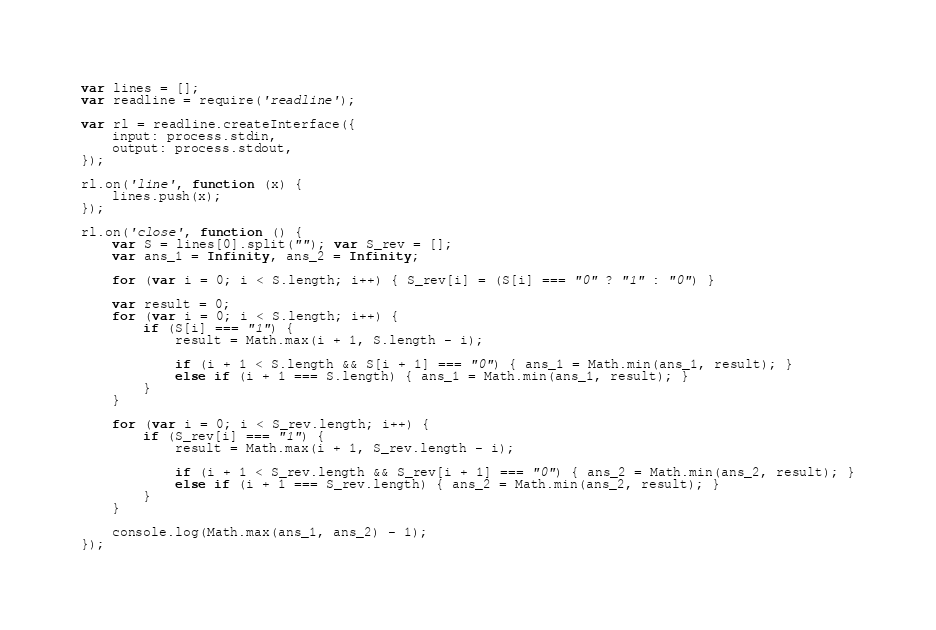Convert code to text. <code><loc_0><loc_0><loc_500><loc_500><_JavaScript_>var lines = [];
var readline = require('readline');

var rl = readline.createInterface({
    input: process.stdin,
    output: process.stdout,
});

rl.on('line', function (x) {
    lines.push(x);
});

rl.on('close', function () {
    var S = lines[0].split(""); var S_rev = [];
    var ans_1 = Infinity, ans_2 = Infinity;

    for (var i = 0; i < S.length; i++) { S_rev[i] = (S[i] === "0" ? "1" : "0") }

    var result = 0;
    for (var i = 0; i < S.length; i++) {
        if (S[i] === "1") {
            result = Math.max(i + 1, S.length - i);

            if (i + 1 < S.length && S[i + 1] === "0") { ans_1 = Math.min(ans_1, result); }
            else if (i + 1 === S.length) { ans_1 = Math.min(ans_1, result); }
        }
    }

    for (var i = 0; i < S_rev.length; i++) {
        if (S_rev[i] === "1") {
            result = Math.max(i + 1, S_rev.length - i);

            if (i + 1 < S_rev.length && S_rev[i + 1] === "0") { ans_2 = Math.min(ans_2, result); }
            else if (i + 1 === S_rev.length) { ans_2 = Math.min(ans_2, result); }
        }
    }

    console.log(Math.max(ans_1, ans_2) - 1);
});</code> 